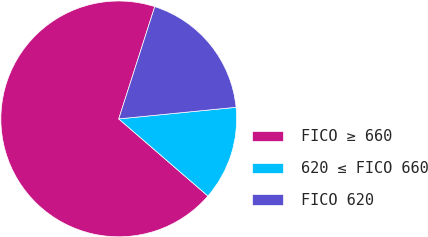Convert chart to OTSL. <chart><loc_0><loc_0><loc_500><loc_500><pie_chart><fcel>FICO ≥ 660<fcel>620 ≤ FICO 660<fcel>FICO 620<nl><fcel>68.59%<fcel>12.92%<fcel>18.49%<nl></chart> 